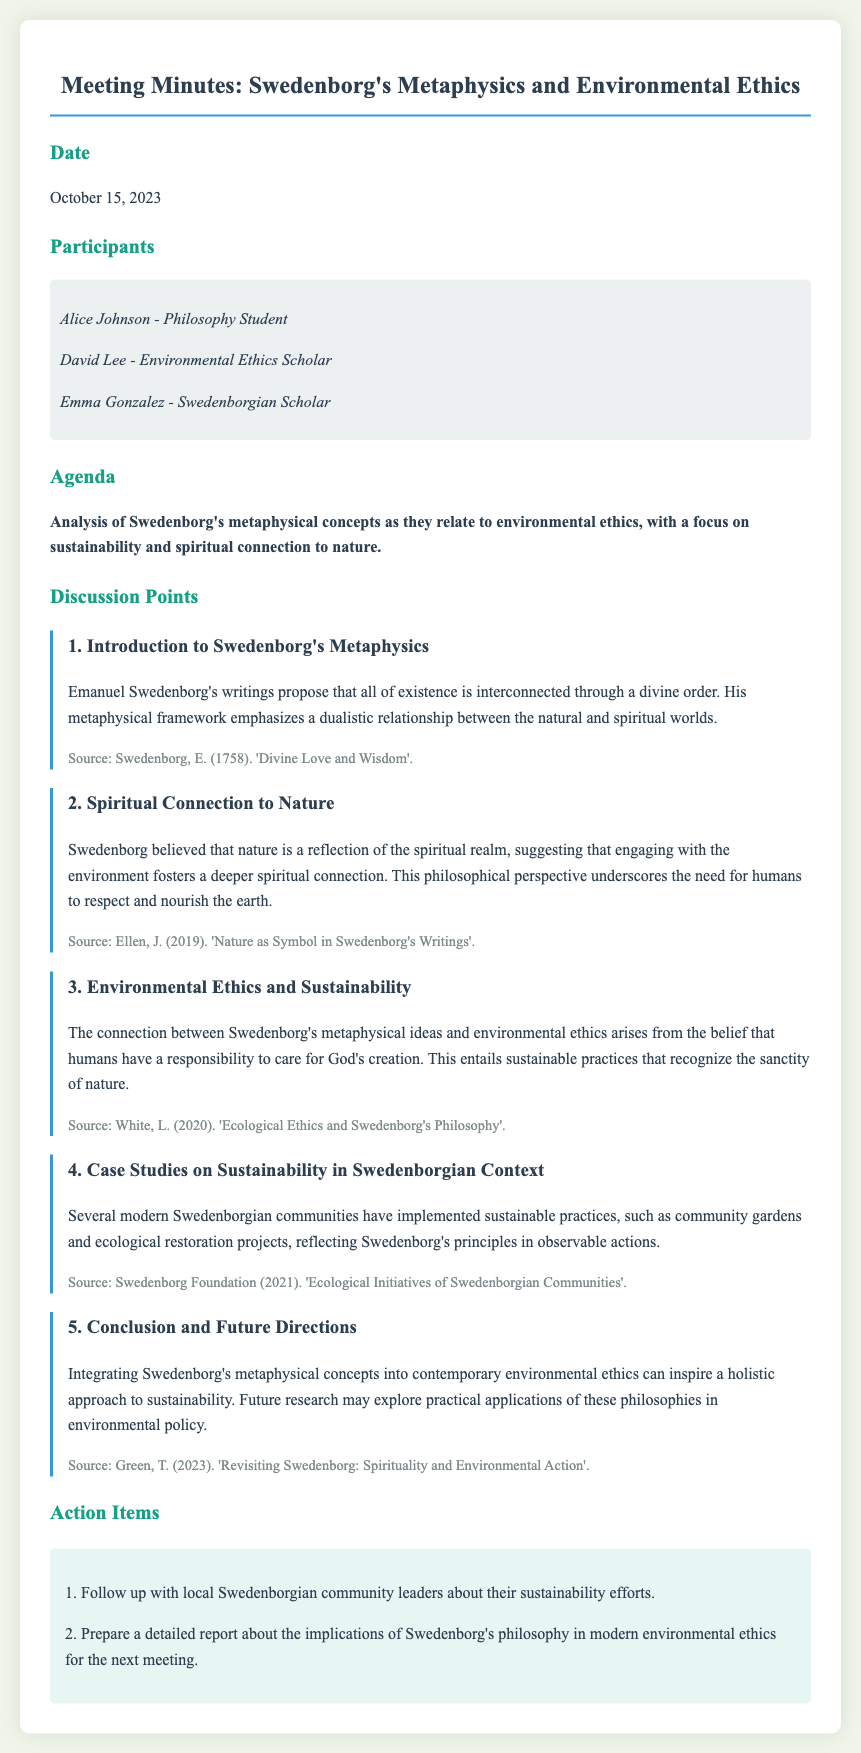What is the date of the meeting? The date is stated clearly in the minutes under the "Date" section.
Answer: October 15, 2023 Who is a participant that is a Philosophy Student? The minutes list the participants and their roles, highlighting Alice Johnson as a Philosophy Student.
Answer: Alice Johnson What was the focus of the agenda? The agenda outlines the main discussion topic related to Swedenborg's concepts and environmental ethics.
Answer: Analysis of Swedenborg's metaphysical concepts as they relate to environmental ethics, with a focus on sustainability and spiritual connection to nature What sustainable practices have been implemented by Swedenborgian communities? The discussion point mentions specific initiatives involving community engagement that reflect Swedenborg's principles in action.
Answer: Community gardens and ecological restoration projects Which source discusses the connection between environmental ethics and Swedenborg's philosophy? Each point cites a source that relates to its content, specifically highlighting White's work.
Answer: White, L. (2020). 'Ecological Ethics and Swedenborg's Philosophy' What are the action items mentioned in the meeting? The document lists particular follow-up actions decided during the meeting for future reference.
Answer: Follow up with local Swedenborgian community leaders about their sustainability efforts 